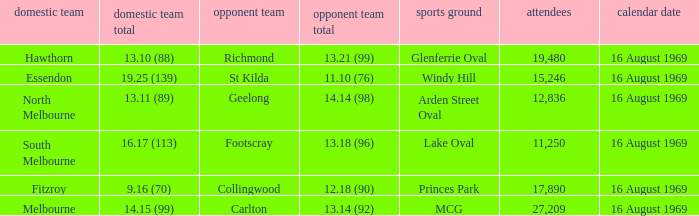What was the away team's score at Princes Park? 12.18 (90). 